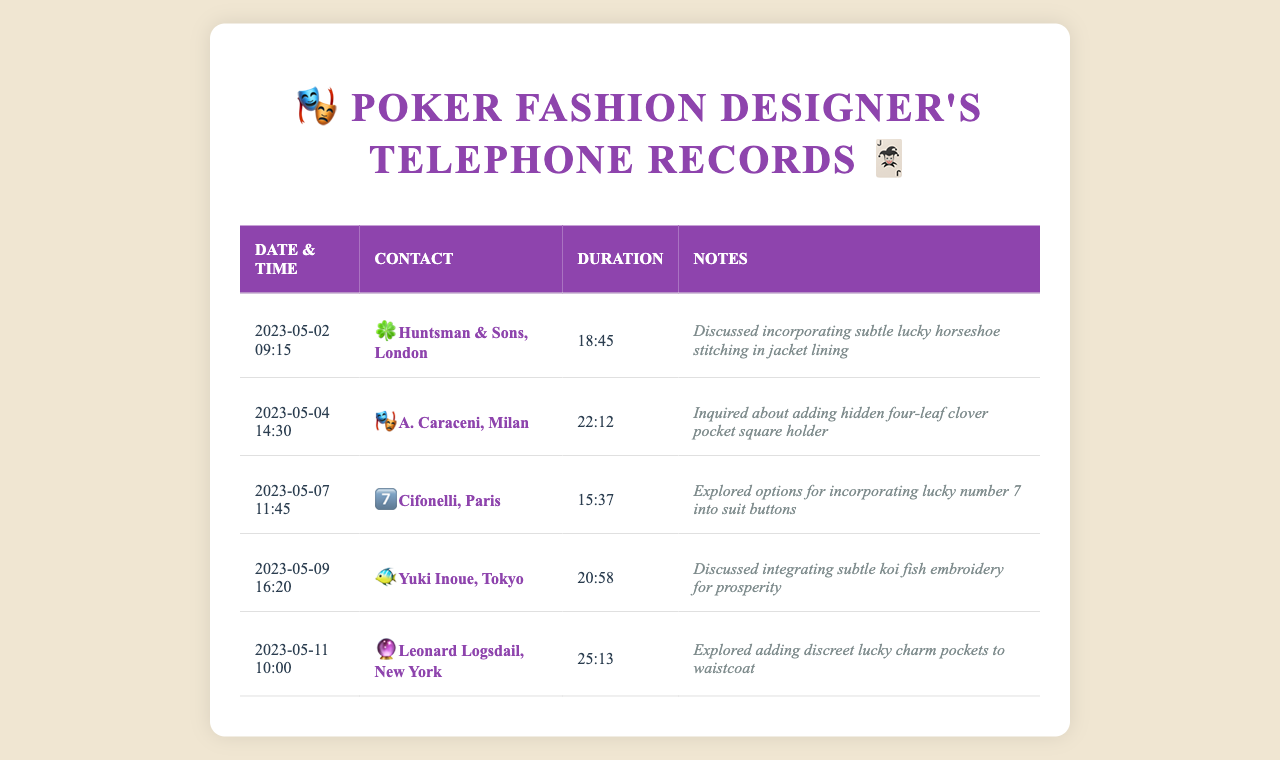what is the name of the tailor in London? The name of the tailor in London is listed in the document under the contact column.
Answer: Huntsman & Sons, London what date was the call to A. Caraceni made? The date of the call to A. Caraceni is specified in the date & time column of the table.
Answer: 2023-05-04 how long was the call with Yuki Inoue? The duration of the call is indicated in the duration column next to Yuki Inoue's entry.
Answer: 20:58 which lucky charm was discussed with Leonard Logsdail? The lucky charm mentioned in the notes for Leonard Logsdail is found in the corresponding row of the table.
Answer: lucky charm pockets how many tailors are mentioned in the document? The total number of tailors can be counted from the number of rows in the table.
Answer: 5 what embroidery was discussed during the call to Yuki Inoue? The type of embroidery discussed with Yuki Inoue can be found in the notes section of the table.
Answer: koi fish embroidery which date has the longest call duration? The longest call duration can be identified by comparing the duration times listed in the document.
Answer: 25:13 did any discussions involve a pocket square? The notes contain mentions that indicate whether a pocket square was discussed.
Answer: Yes 